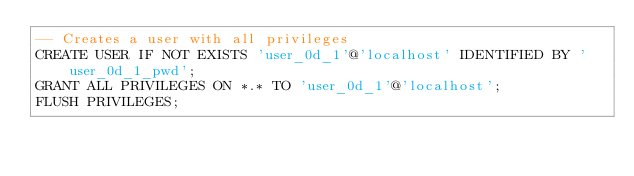Convert code to text. <code><loc_0><loc_0><loc_500><loc_500><_SQL_>-- Creates a user with all privileges
CREATE USER IF NOT EXISTS 'user_0d_1'@'localhost' IDENTIFIED BY 'user_0d_1_pwd';
GRANT ALL PRIVILEGES ON *.* TO 'user_0d_1'@'localhost';
FLUSH PRIVILEGES;
</code> 